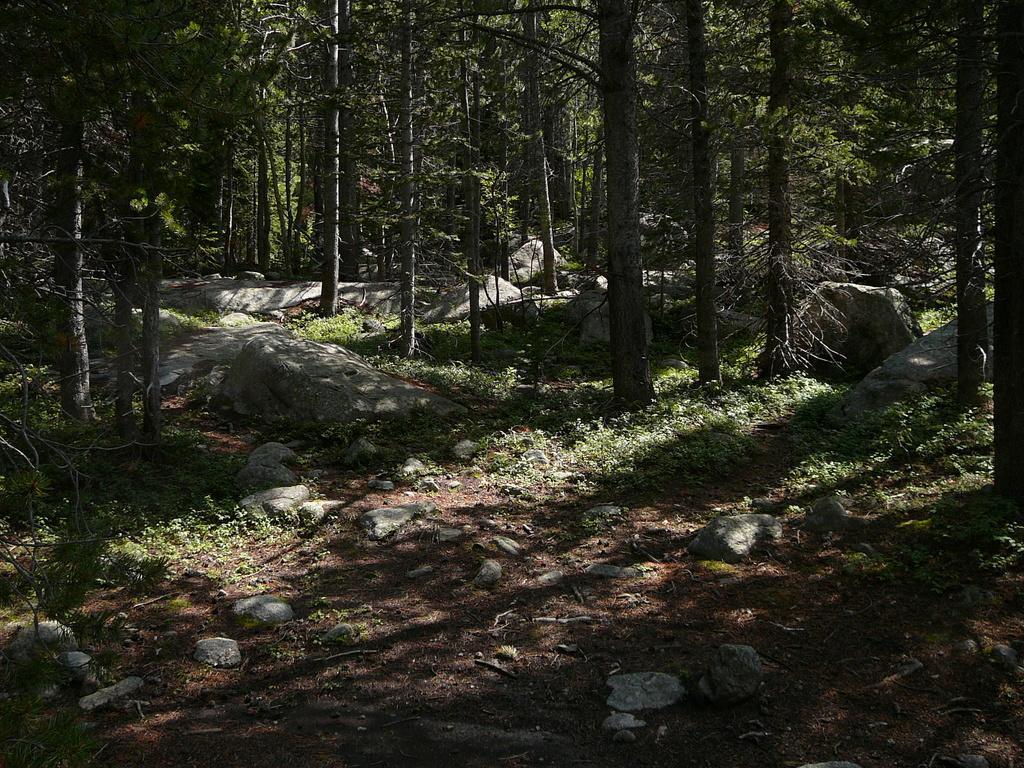Can you describe this image briefly? In this image we can see many trees and plants. There are rocks in the image. 